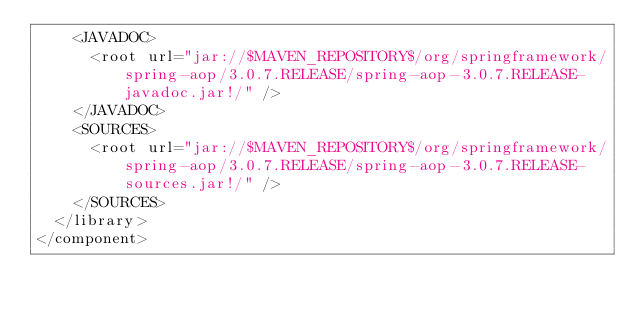<code> <loc_0><loc_0><loc_500><loc_500><_XML_>    <JAVADOC>
      <root url="jar://$MAVEN_REPOSITORY$/org/springframework/spring-aop/3.0.7.RELEASE/spring-aop-3.0.7.RELEASE-javadoc.jar!/" />
    </JAVADOC>
    <SOURCES>
      <root url="jar://$MAVEN_REPOSITORY$/org/springframework/spring-aop/3.0.7.RELEASE/spring-aop-3.0.7.RELEASE-sources.jar!/" />
    </SOURCES>
  </library>
</component></code> 